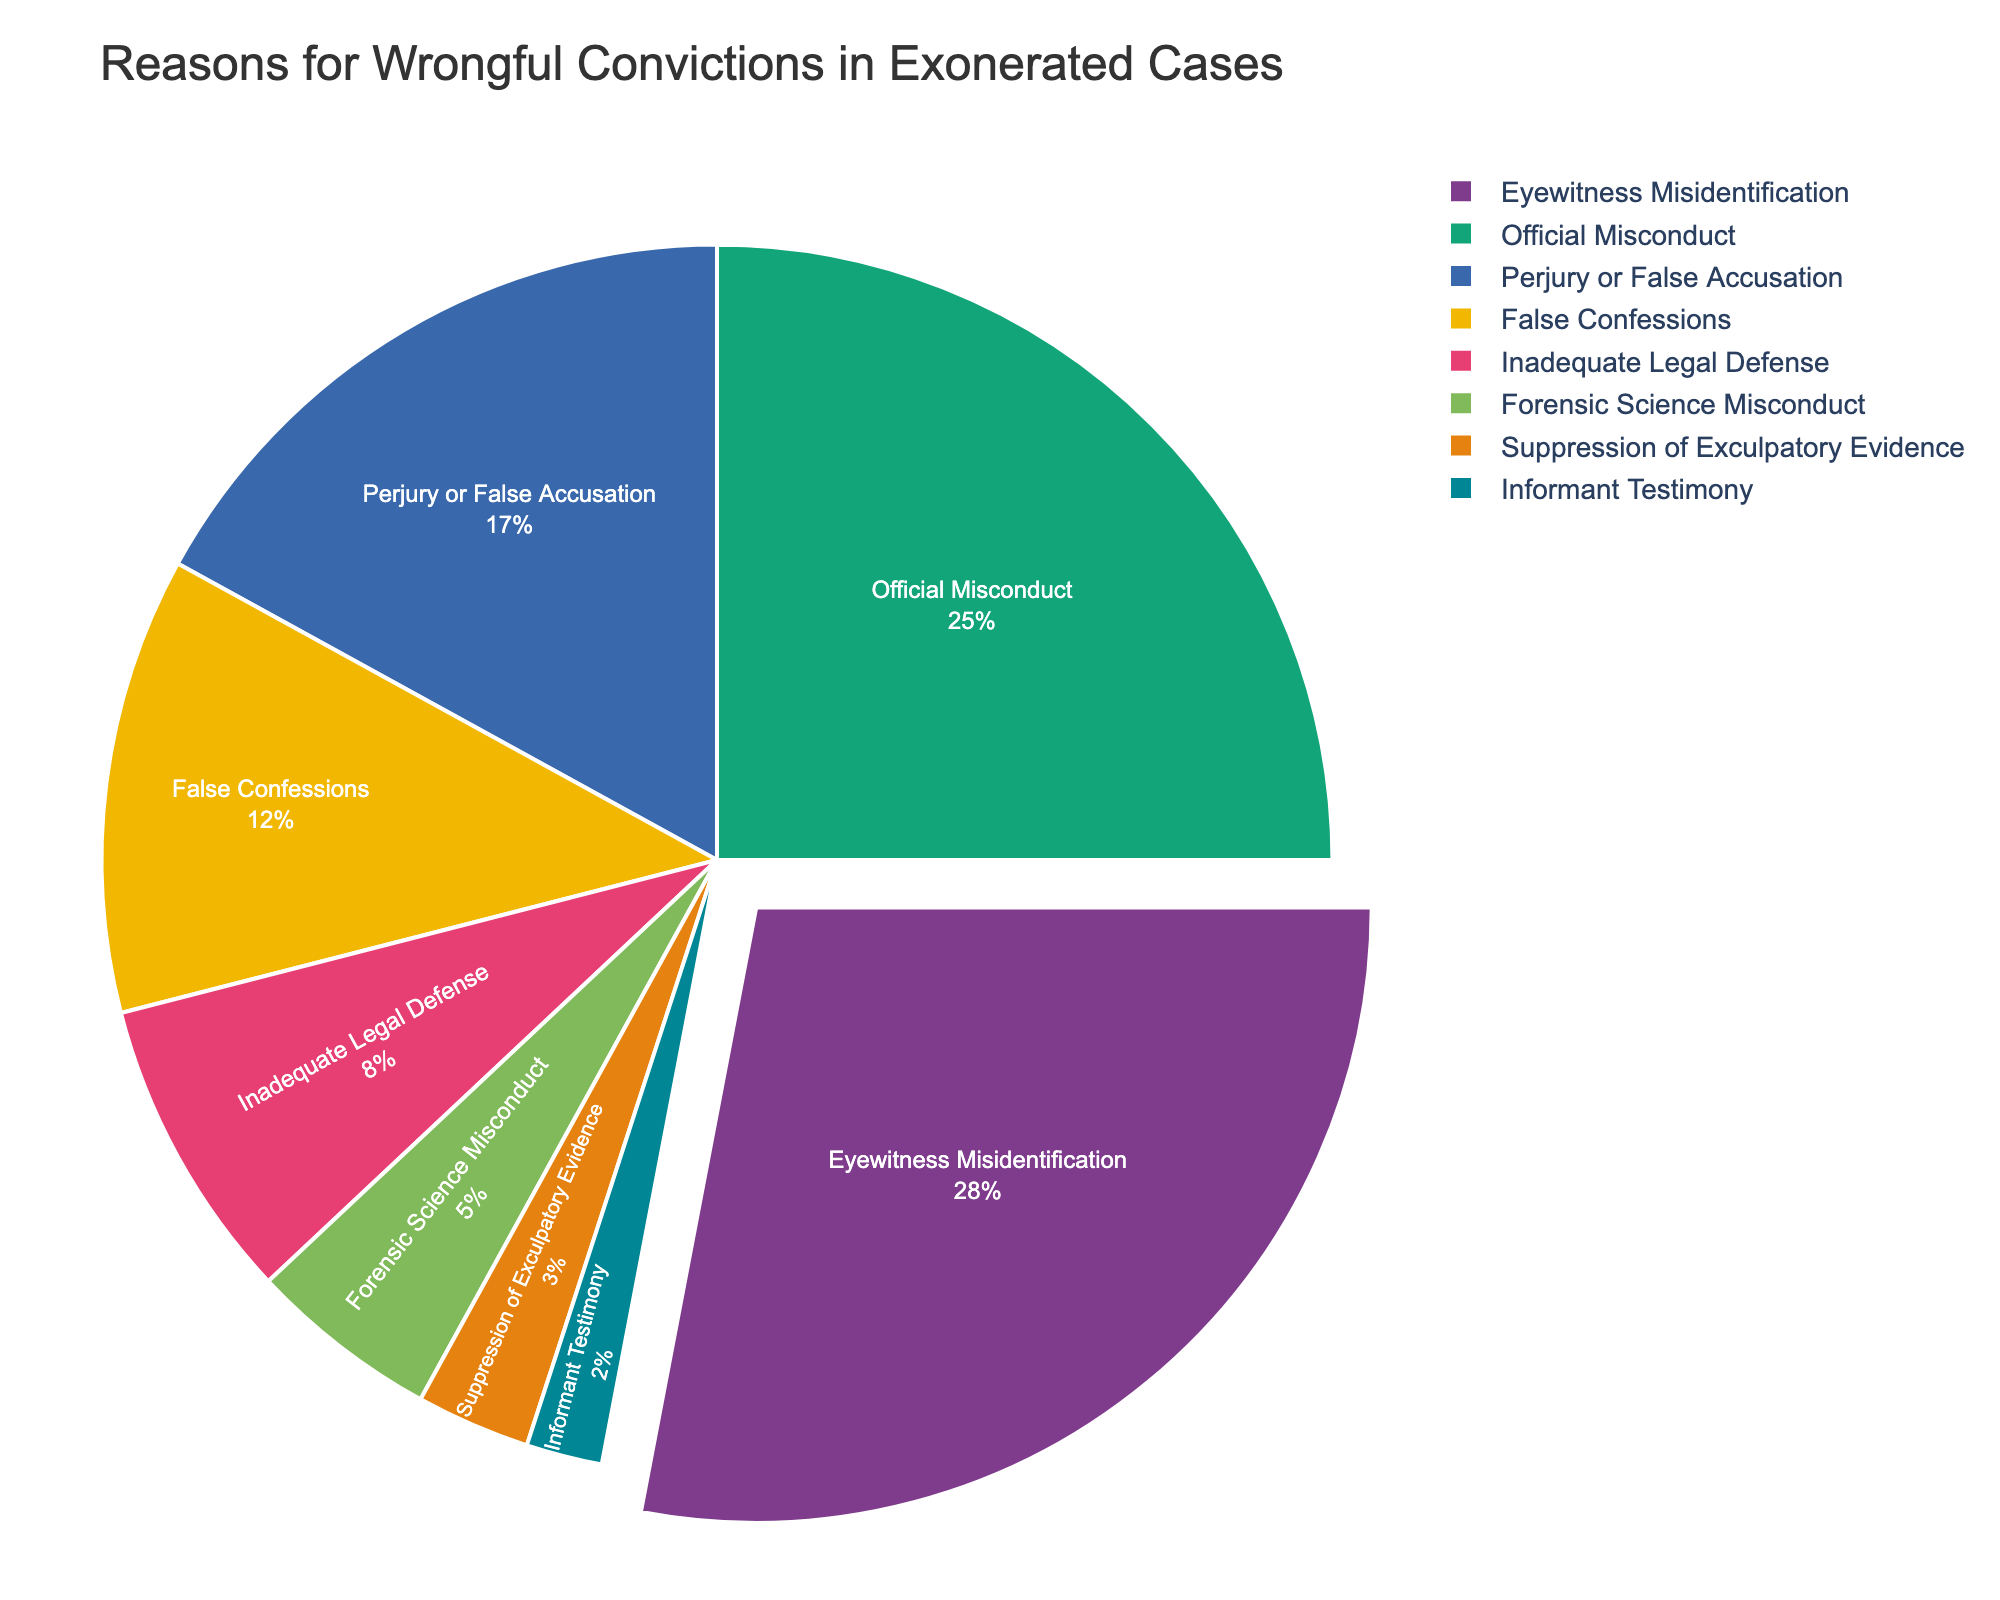What's the most common reason for wrongful convictions in exonerated cases? The pie chart shows that the largest segment is for "Eyewitness Misidentification" at 28%, indicating it is the most common reason.
Answer: Eyewitness Misidentification How much higher is the percentage of wrongful convictions due to eyewitness misidentification compared to inadequate legal defense? Eyewitness Misidentification is 28% and Inadequate Legal Defense is 8%. Subtracting 8 from 28 gives the difference.
Answer: 20% What percentage of wrongful convictions is due to Official Misconduct and False Confessions combined? The percentages for Official Misconduct and False Confessions are 25% and 12%, respectively. Adding them gives the total contribution.
Answer: 37% Is the percentage of wrongful convictions due to Forensic Science Misconduct greater than the percentage due to Suppression of Exculpatory Evidence? Forensic Science Misconduct is 5% while Suppression of Exculpatory Evidence is 3%. Since 5% is greater than 3%, the answer is yes.
Answer: Yes Which reason for wrongful convictions has the smallest percentage, and what is that percentage? By looking at the pie chart, Informant Testimony has the smallest segment, making up 2% of the reasons.
Answer: Informant Testimony, 2% How many percentage points separate Perjury or False Accusation from False Confessions? Perjury or False Accusation is 17% and False Confessions is 12%. Subtract 12 from 17 to get the difference.
Answer: 5 In terms of visual area, which pie segment occupies the second largest portion of the chart and what reason does it represent? After identifying the largest, focus on the next largest pie area, which corresponds to Official Misconduct.
Answer: Official Misconduct If you combine the percentages of Forensic Science Misconduct, Suppression of Exculpatory Evidence, and Informant Testimony, what do you get? Adding the percentages of Forensic Science Misconduct (5%), Suppression of Exculpatory Evidence (3%), and Informant Testimony (2%), we get 10%.
Answer: 10% Does False Confessions have a larger or smaller segment than Perjury or False Accusation in the pie chart? By comparing the slices, False Confessions has a smaller segment (12%) compared to Perjury or False Accusation (17%).
Answer: Smaller Among the listed reasons, which one has a percentage closest to 25%? Official Misconduct is listed at precisely 25%, making it the closest data point.
Answer: Official Misconduct 